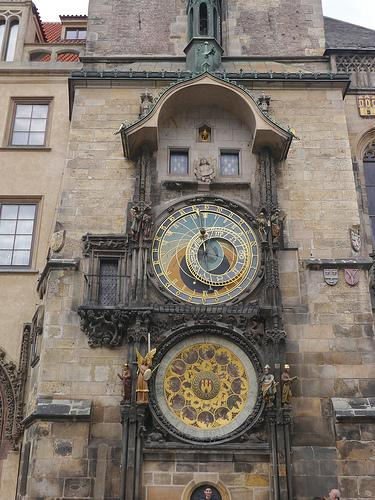Describe the unique features of the building's roof. The roof consists of brown tiles and a red slate, which is adorned by a weather vane on point. Describe the positions and actions of people in the image. A person is standing under an archway, while another individual looks at the building, and a man stands in front of the clock. Briefly describe the statues present in the image and their positions relative to the clock. There are statues of angels and men, some hold shields and books, and they are positioned next to or above the round ornate clock. Tell what a person is doing near the building. A man is standing in front of the building, looking at it while situated under an archway. Mention the types of windows on the building and their characteristics. There are rose-style glass windows with star patterns within the circular frames and small, rectangular windows with square frames. Mention the most prominent architectural feature in the image with its color and shape. A large round clock with gold and black details is the most prominent architectural feature in the image. Identify the main building material seen on the structure and a notable window design. The building is made of worn-out brick material and features a rose-style glass window with a star pattern. Enumerate three distinct objects inside the image you can find and provide their brief descriptions. A large golden wings on an angel statue, an angel holding a round shield, and a single window stand with a rectangular shape. Comment on the notable decorative elements and sculptures on the building. The building showcases decorative stone ledges, angel and man sculptures with golden wings, and carvings of shields mounted on the wall. Explain the design and appearance of the clock face. The clock face is fancy, circular, and displays a medieval-style with gold artwork and a castle in the middle. 